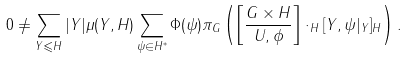<formula> <loc_0><loc_0><loc_500><loc_500>0 \neq \sum _ { Y \leqslant H } | Y | \mu ( Y , H ) \sum _ { \psi \in H ^ { * } } \Phi ( \psi ) \pi _ { G } \left ( \left [ \frac { G \times H } { U , \phi } \right ] \cdot _ { H } [ Y , \psi | _ { Y } ] _ { H } \right ) .</formula> 